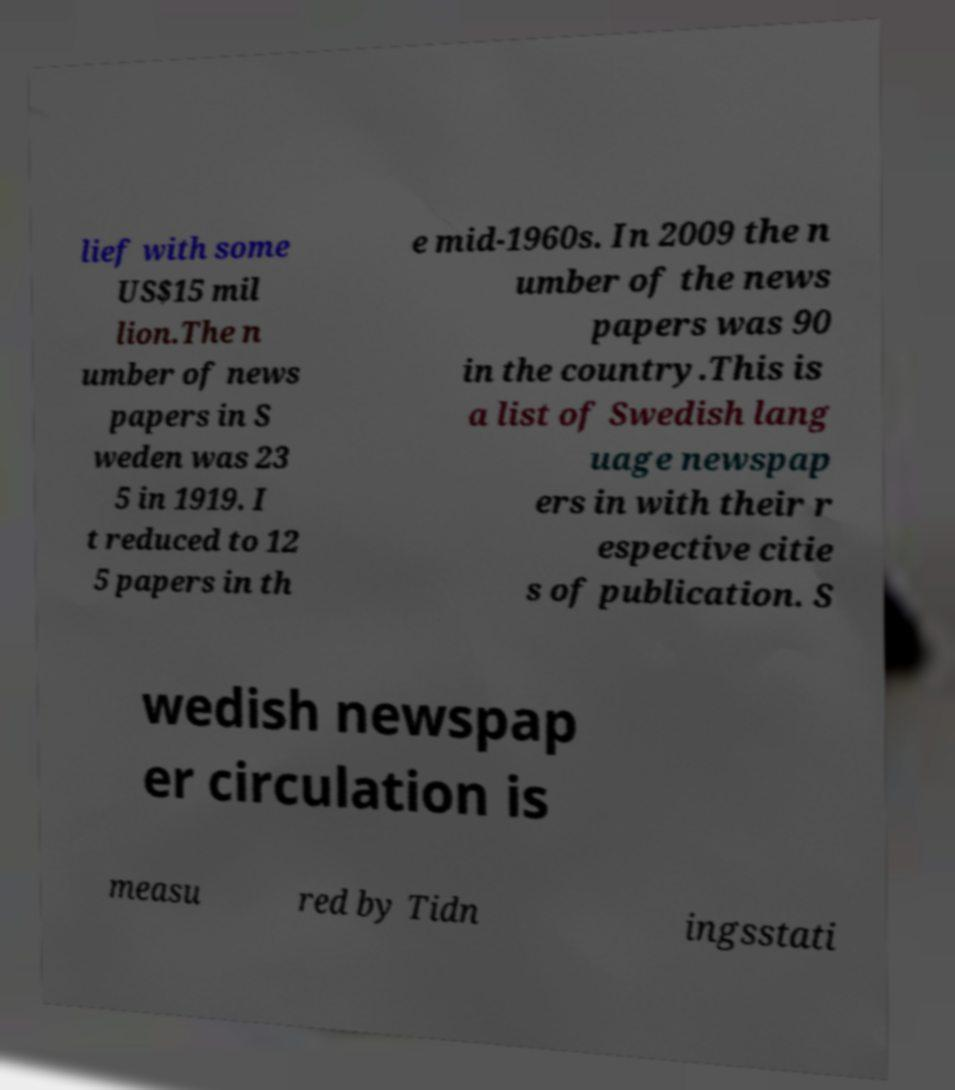There's text embedded in this image that I need extracted. Can you transcribe it verbatim? lief with some US$15 mil lion.The n umber of news papers in S weden was 23 5 in 1919. I t reduced to 12 5 papers in th e mid-1960s. In 2009 the n umber of the news papers was 90 in the country.This is a list of Swedish lang uage newspap ers in with their r espective citie s of publication. S wedish newspap er circulation is measu red by Tidn ingsstati 